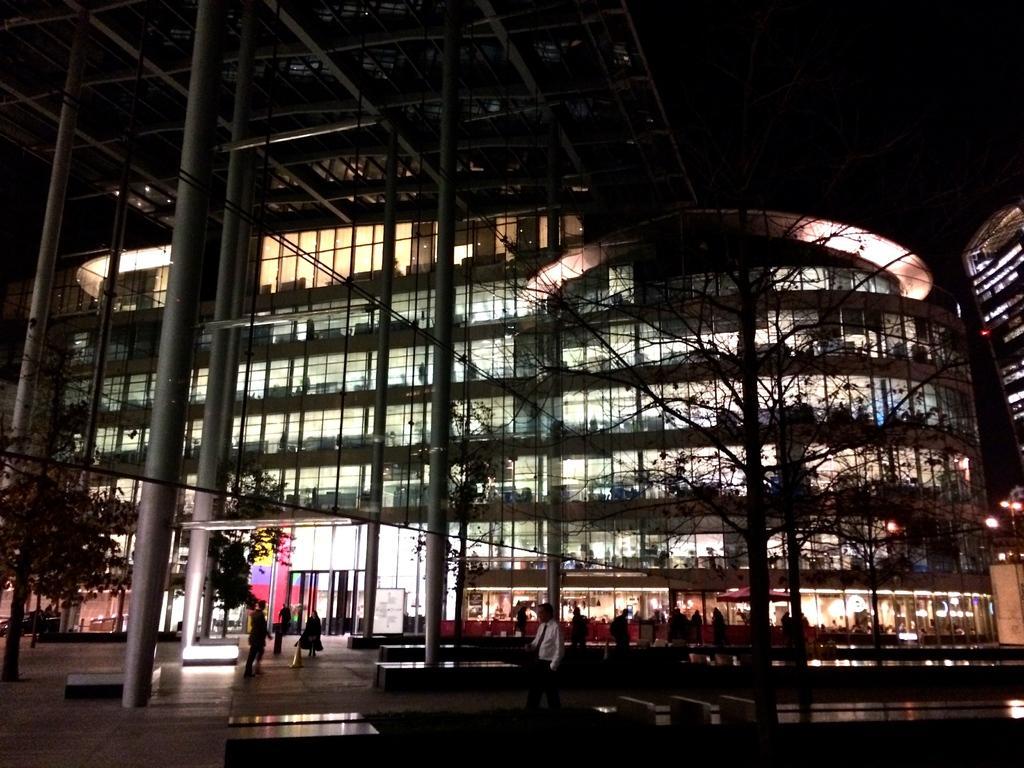Please provide a concise description of this image. This image is taken during the night time. In this image we can see the building with the glass windows in the middle. In front of it there are so many pillars. On the right side there are trees. At the bottom there are few people walking on the floor. On the left side there are so many trees. In the middle there is an entrance. 